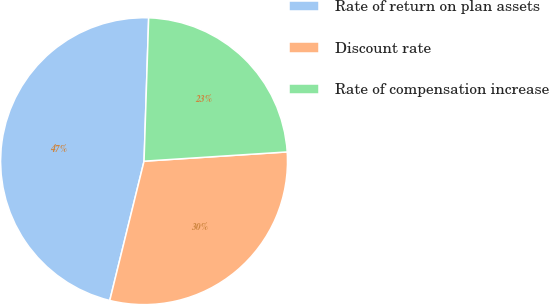<chart> <loc_0><loc_0><loc_500><loc_500><pie_chart><fcel>Rate of return on plan assets<fcel>Discount rate<fcel>Rate of compensation increase<nl><fcel>46.67%<fcel>29.87%<fcel>23.46%<nl></chart> 